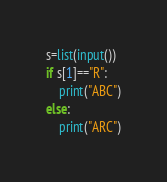Convert code to text. <code><loc_0><loc_0><loc_500><loc_500><_Python_>s=list(input())
if s[1]=="R":
    print("ABC")
else:
    print("ARC")</code> 